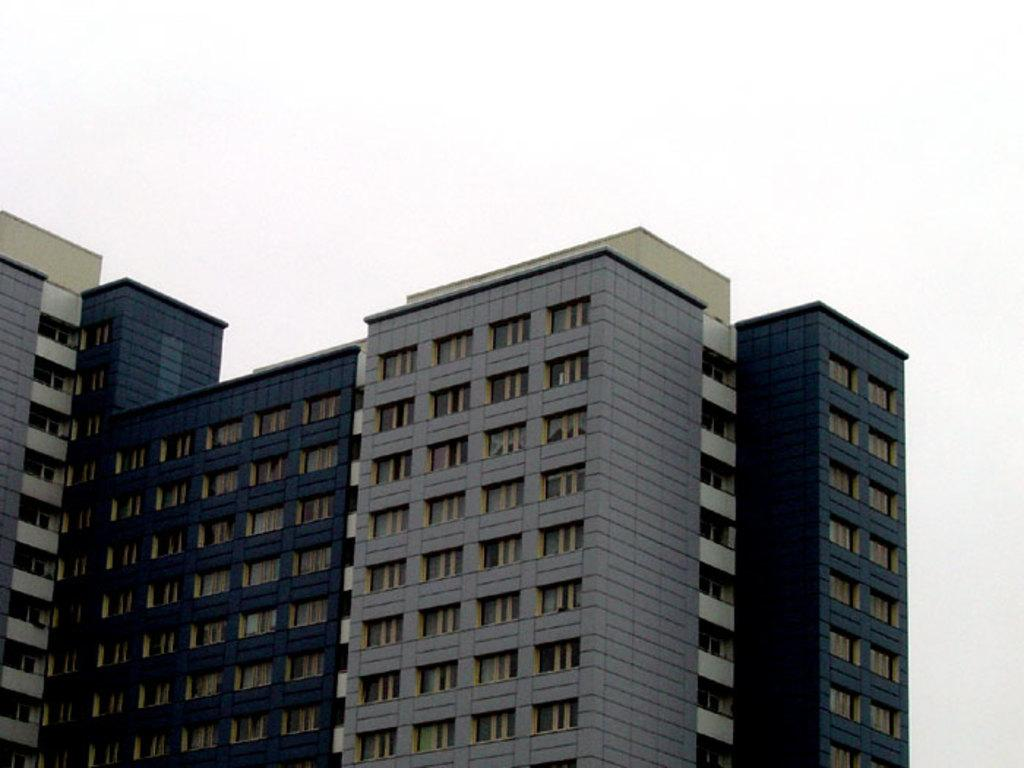What structures are present in the image? There are buildings in the image. What color is the background of the image? The background of the image is white. How does the afterthought contribute to the growth of the stitch in the image? There is no afterthought, growth, or stitch present in the image; it only features buildings and a white background. 